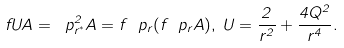<formula> <loc_0><loc_0><loc_500><loc_500>f U A = \ p _ { r ^ { * } } ^ { 2 } A = f \ p _ { r } ( f \ p _ { r } A ) , \, U = \frac { 2 } { r ^ { 2 } } + \frac { 4 Q ^ { 2 } } { r ^ { 4 } } .</formula> 